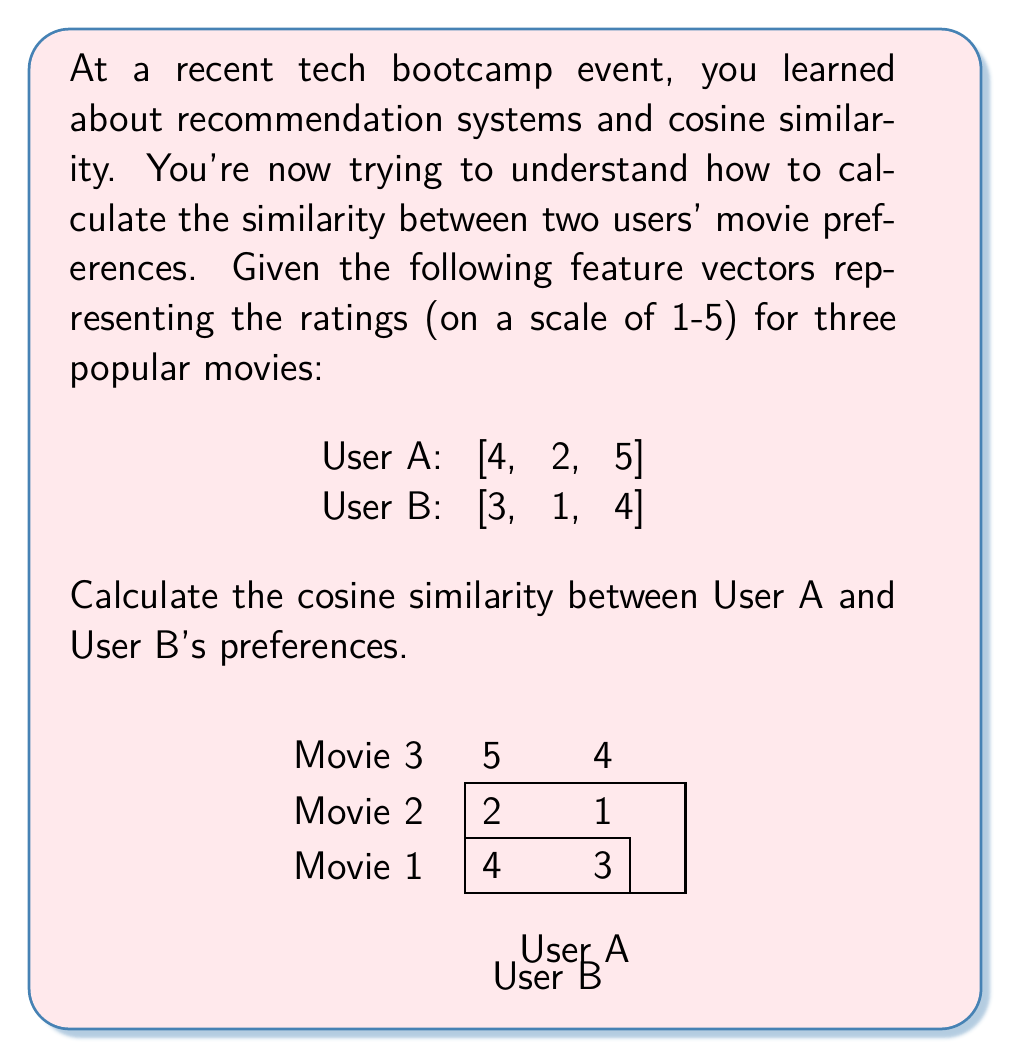Give your solution to this math problem. Let's calculate the cosine similarity step by step:

1) The formula for cosine similarity between two vectors A and B is:

   $$\text{cosine similarity} = \frac{A \cdot B}{\|A\| \|B\|}$$

   where $A \cdot B$ is the dot product, and $\|A\|$ and $\|B\|$ are the magnitudes of vectors A and B.

2) Calculate the dot product $A \cdot B$:
   $$(4 \times 3) + (2 \times 1) + (5 \times 4) = 12 + 2 + 20 = 34$$

3) Calculate the magnitude of vector A:
   $$\|A\| = \sqrt{4^2 + 2^2 + 5^2} = \sqrt{16 + 4 + 25} = \sqrt{45}$$

4) Calculate the magnitude of vector B:
   $$\|B\| = \sqrt{3^2 + 1^2 + 4^2} = \sqrt{9 + 1 + 16} = \sqrt{26}$$

5) Now, substitute these values into the cosine similarity formula:

   $$\text{cosine similarity} = \frac{34}{\sqrt{45} \times \sqrt{26}}$$

6) Simplify:
   $$\text{cosine similarity} = \frac{34}{\sqrt{1170}} \approx 0.9933$$

The cosine similarity ranges from -1 to 1, with 1 indicating perfect similarity. This high value (close to 1) suggests that User A and User B have very similar movie preferences.
Answer: $0.9933$ 